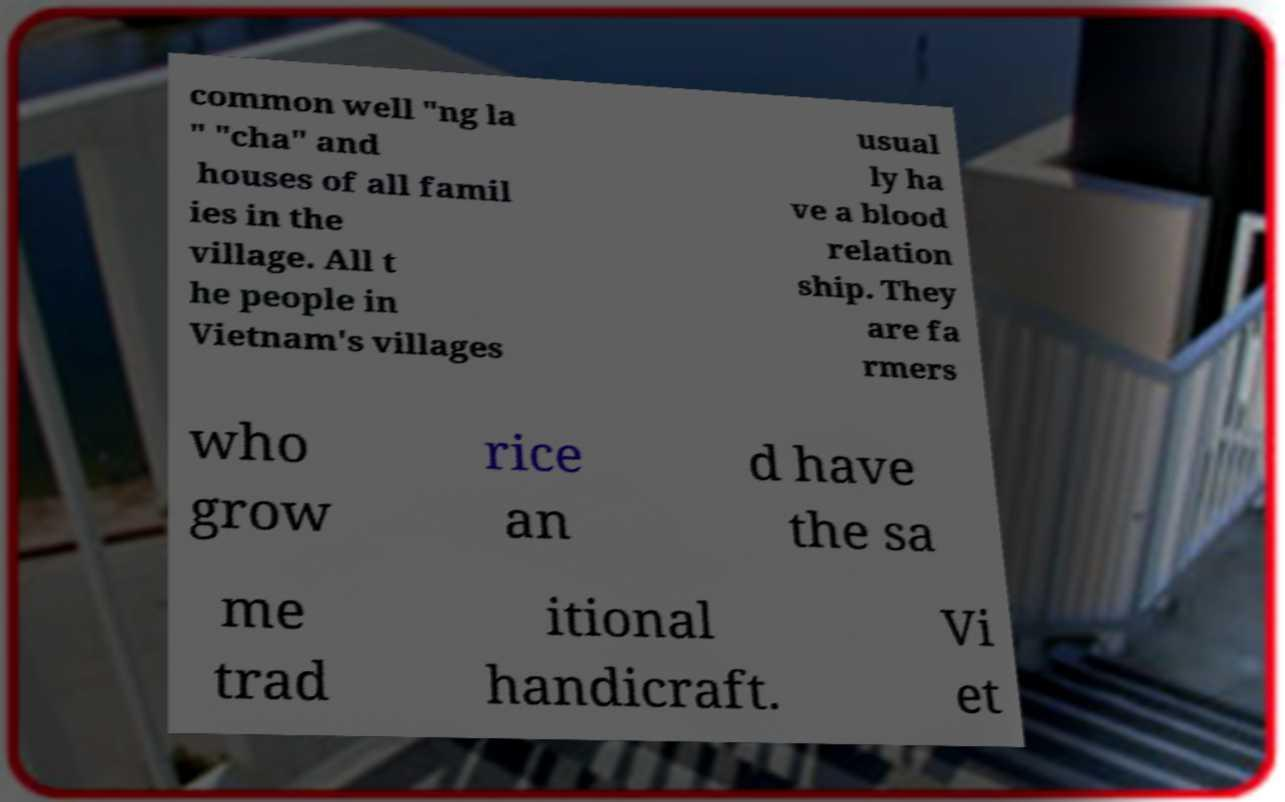What messages or text are displayed in this image? I need them in a readable, typed format. common well "ng la " "cha" and houses of all famil ies in the village. All t he people in Vietnam's villages usual ly ha ve a blood relation ship. They are fa rmers who grow rice an d have the sa me trad itional handicraft. Vi et 